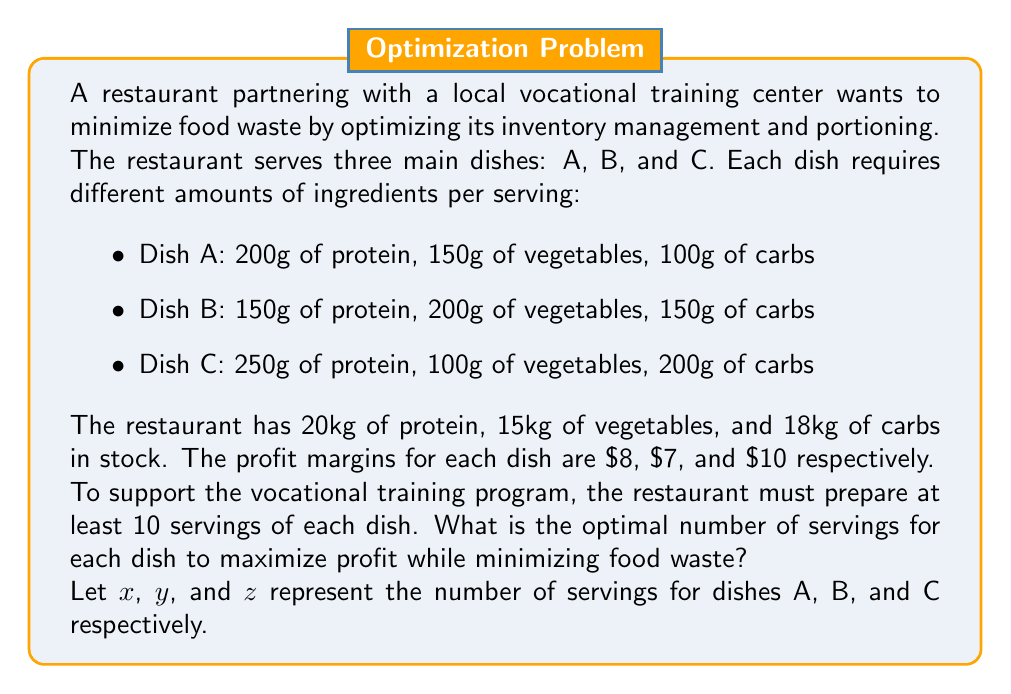Solve this math problem. To solve this optimization problem, we'll use linear programming. We need to:
1. Define the objective function
2. Set up the constraints
3. Solve the linear programming problem

1. Objective function:
   Maximize profit: $P = 8x + 7y + 10z$

2. Constraints:
   a) Ingredient limitations:
      Protein: $200x + 150y + 250z \leq 20000$
      Vegetables: $150x + 200y + 100z \leq 15000$
      Carbs: $100x + 150y + 200z \leq 18000$
   
   b) Minimum servings requirement:
      $x \geq 10$
      $y \geq 10$
      $z \geq 10$
   
   c) Non-negativity:
      $x, y, z \geq 0$

3. Solving the linear programming problem:
   We can use the simplex method or a linear programming solver to find the optimal solution. Using a solver, we get:

   $x = 10$ (Dish A)
   $y = 10$ (Dish B)
   $z = 62$ (Dish C)

   This solution maximizes profit while satisfying all constraints.

Let's verify the solution:

Protein used: $200(10) + 150(10) + 250(62) = 19000g$ (out of 20000g)
Vegetables used: $150(10) + 200(10) + 100(62) = 9700g$ (out of 15000g)
Carbs used: $100(10) + 150(10) + 200(62) = 15900g$ (out of 18000g)

Total profit: $P = 8(10) + 7(10) + 10(62) = 770$

This solution minimizes food waste by using most of the available ingredients while maximizing profit and meeting the minimum serving requirements for the vocational training program.
Answer: The optimal number of servings to maximize profit while minimizing food waste is:
Dish A: 10 servings
Dish B: 10 servings
Dish C: 62 servings 